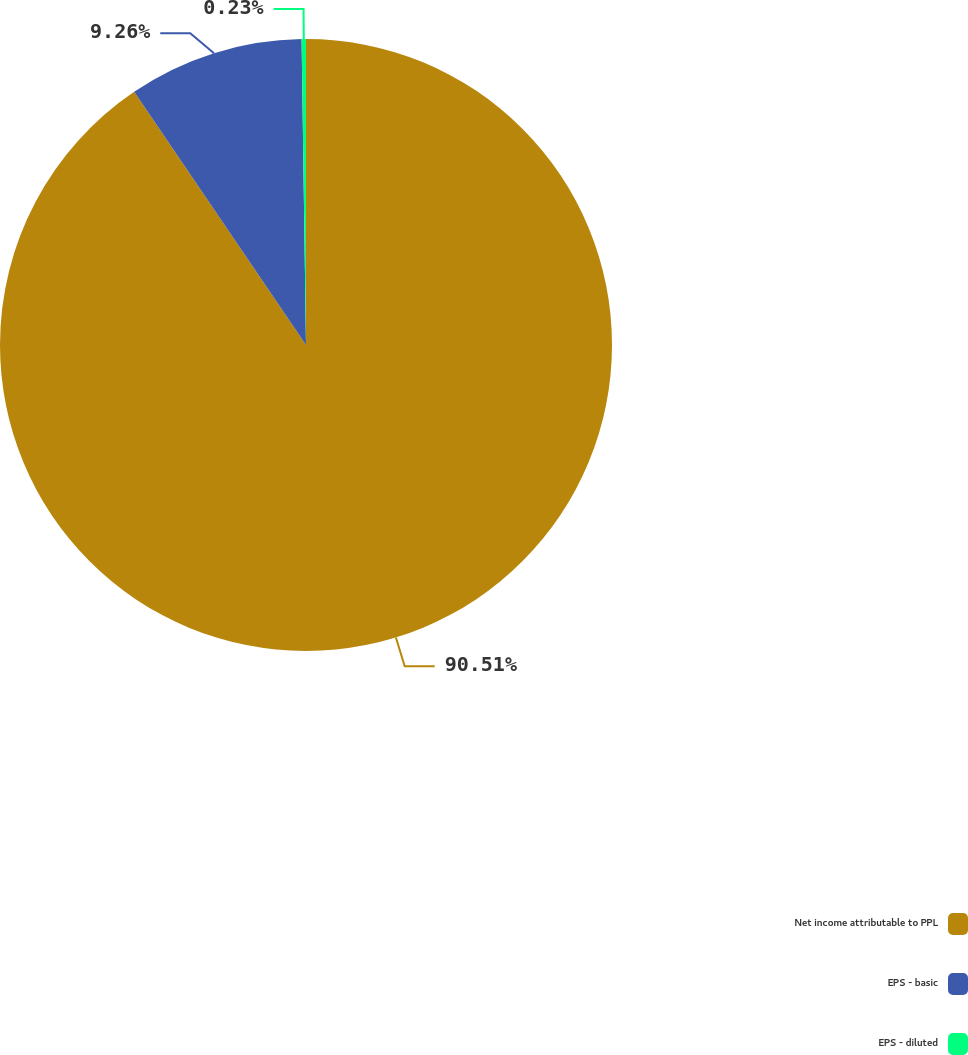<chart> <loc_0><loc_0><loc_500><loc_500><pie_chart><fcel>Net income attributable to PPL<fcel>EPS - basic<fcel>EPS - diluted<nl><fcel>90.5%<fcel>9.26%<fcel>0.23%<nl></chart> 